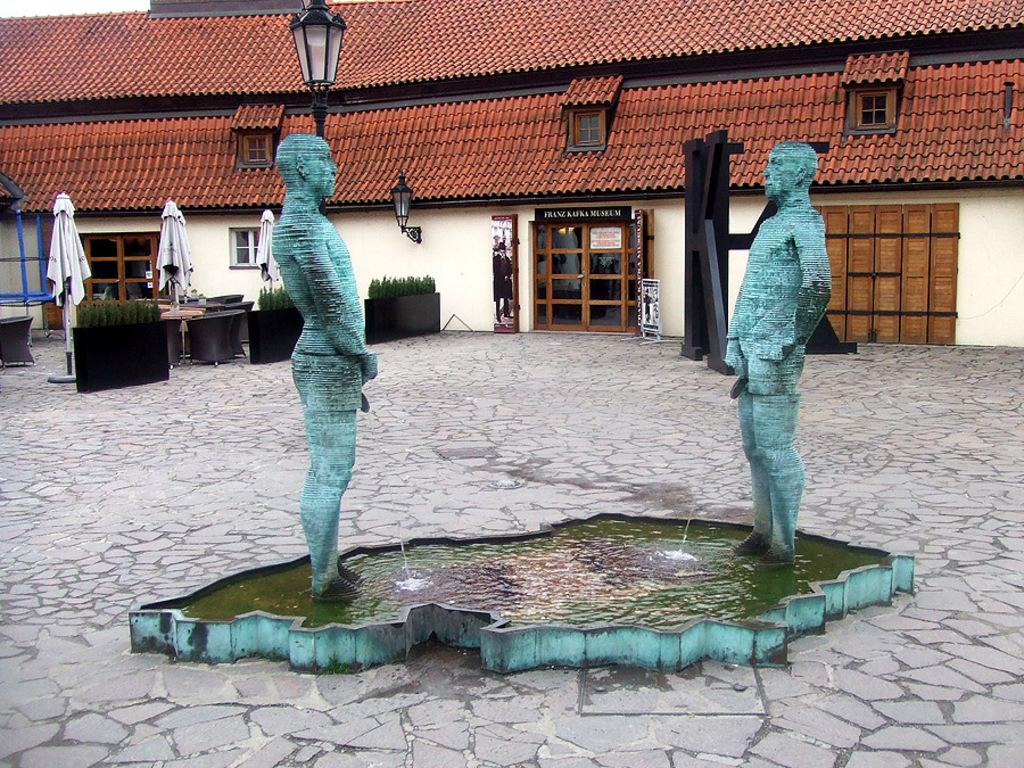What can be seen in the image that represents artistic creations? There are statues in the image. What type of structure is located at the back of the image? There is a building at the back side of the image. What decorative items are present in front of the building? Flower pots are present in front of the building. What type of furniture is visible in front of the building? Chairs are visible in front of the building. What type of illumination is present in front of the building? Lights are present in front of the building. Can you tell me how many veins are visible on the statues in the image? There is no mention of veins on the statues in the image, so it is not possible to answer that question. What type of park can be seen in the image? There is no park present in the image; it features statues, a building, flower pots, chairs, and lights. 